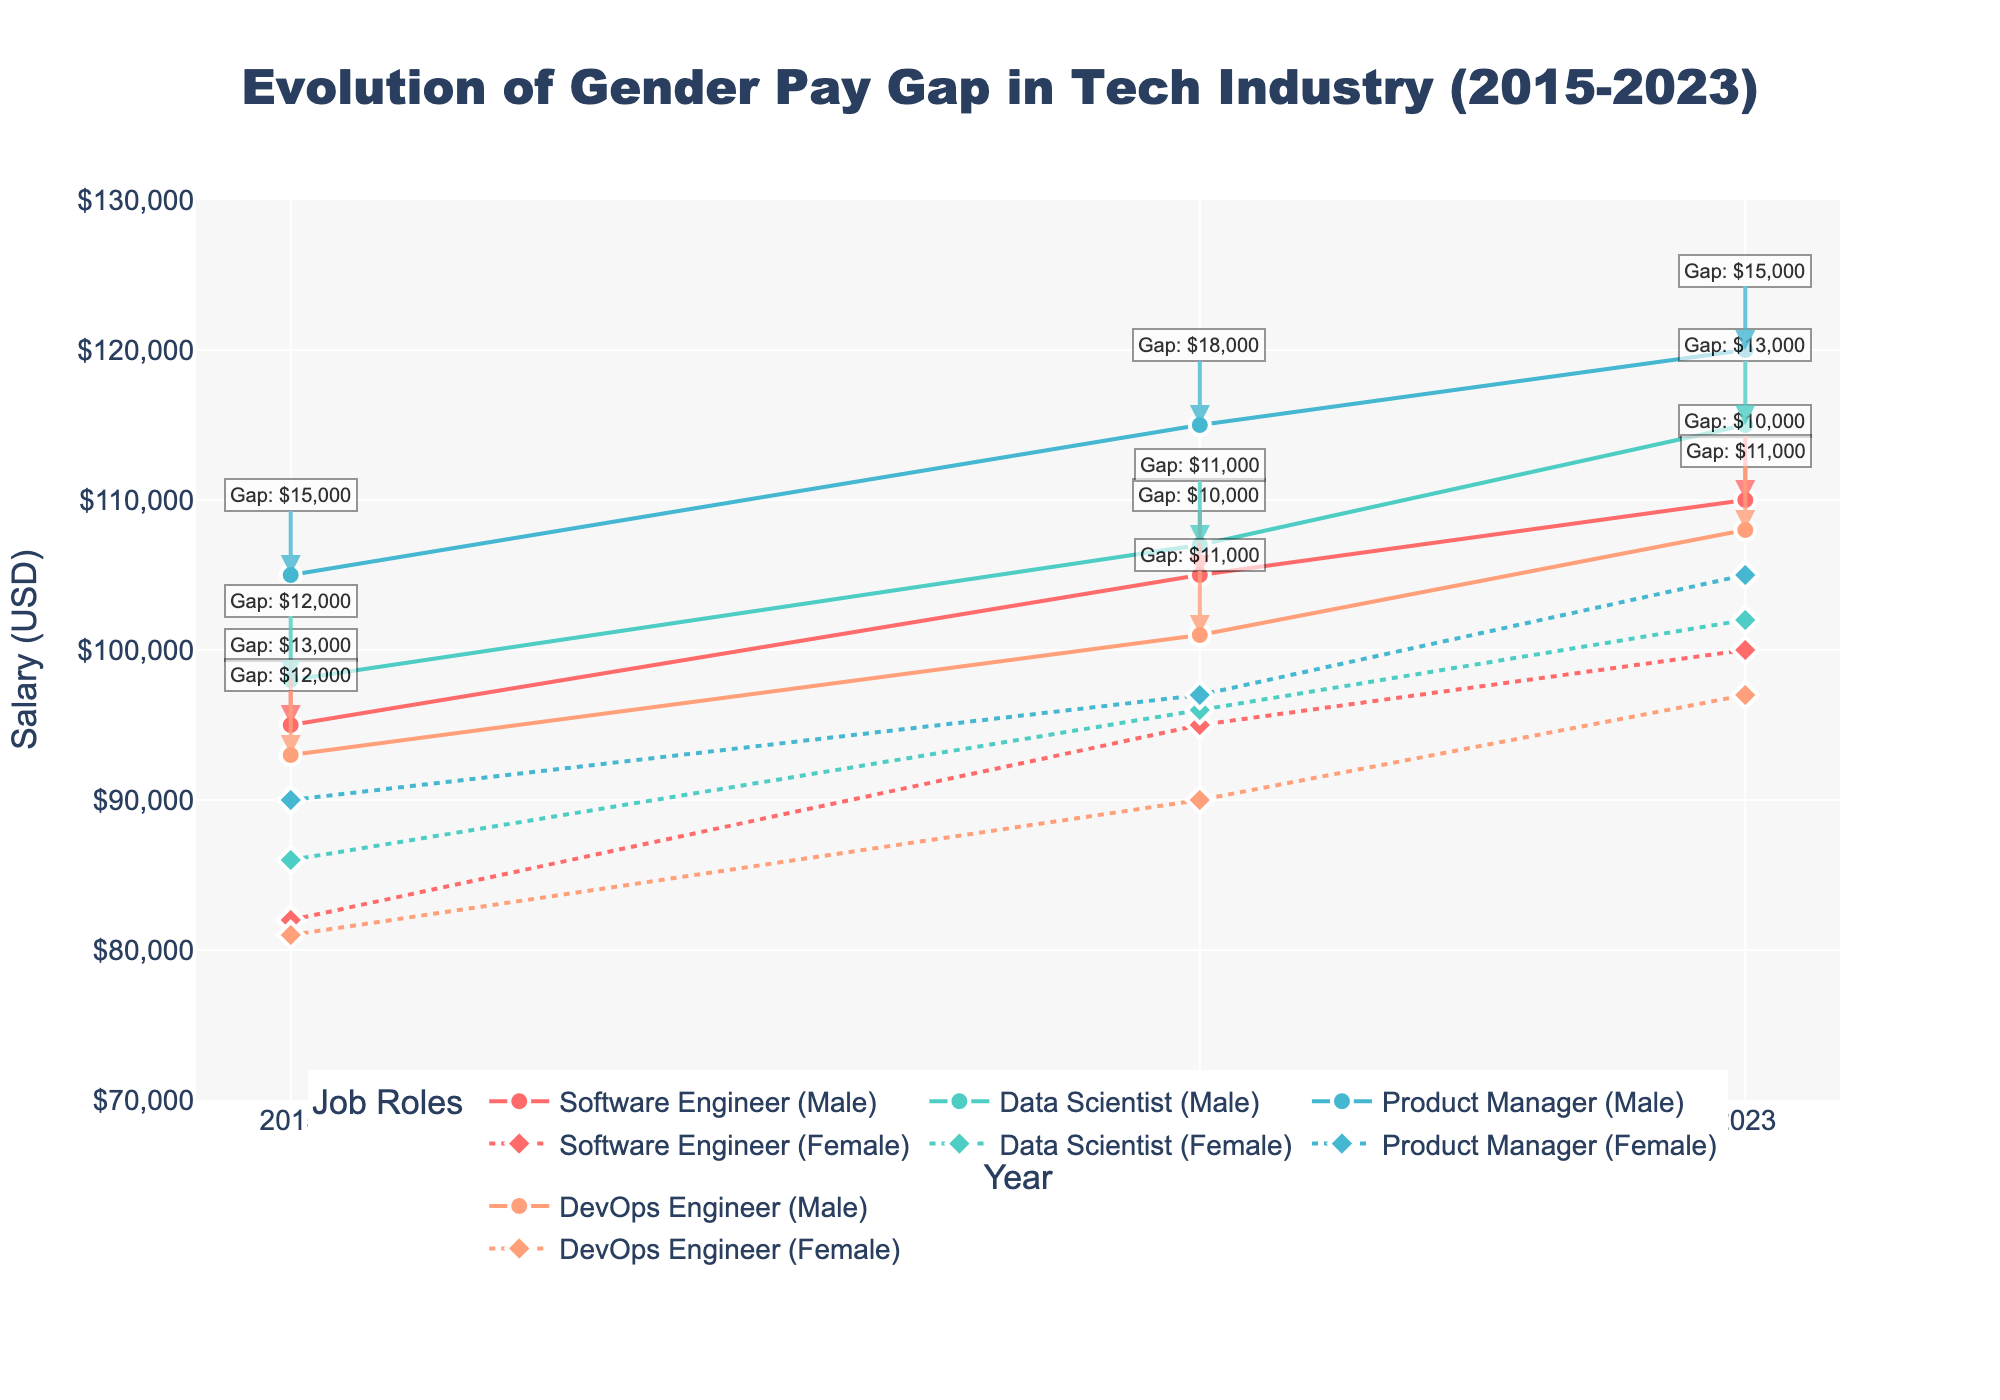What is the title of the plot? The title of the plot is often located at the top and gives an overview of the figure. In this case, it reads: "Evolution of Gender Pay Gap in Tech Industry (2015-2023)".
Answer: Evolution of Gender Pay Gap in Tech Industry (2015-2023) Which job role had the largest average male salary in 2023? By looking at the markers and lines representing male salaries for each job role in 2023 on the figure, the Product Manager role has the highest point.
Answer: Product Manager How much was the gender pay gap for Software Engineers in 2020? The gap is annotated next to the 2020 data points for Software Engineers. The annotation reads "Gap: $10,000".
Answer: $10,000 Between 2015 and 2023, which job role showed the greatest increase in average female salary? By observing the differences in heights of markers for female salaries from 2015 to 2023, Data Scientist shows the most significant increase. The difference is visible significantly more than other roles.
Answer: Data Scientist In 2023, which job role had a smaller pay gap, Software Engineers or DevOps Engineers? By comparing the annotations for the pay gap of Software Engineers and DevOps Engineers in 2023, DevOps Engineers had a smaller gap of "Gap: $11,000" compared to Software Engineers' "Gap: $10,000".
Answer: DevOps Engineers What is the color used for the line and markers representing DevOps Engineers? The color for each job role is consistent throughout. DevOps Engineers are represented by the line and markers in the color salmon (#FFA07A).
Answer: Salmon Which year shows the smallest gender pay gap for Product Managers? The smallest pay gap for Product Managers can be identified by looking at the annotated values. In 2023, the pay gap annotation reads "Gap: $15,000", which is smaller than previous years.
Answer: 2023 How much did the average male salary for Data Scientists increase from 2015 to 2023? Starting from the 2015 average male salary ($98,000) to the 2023 average ($115,000), the increase is calculated as $115,000 - $98,000.
Answer: $17,000 In 2020, did the gap for Data Scientists exceed $10,000? By checking the annotation next to the 2020 data points for Data Scientists, the gap is shown as $11,000.
Answer: Yes 